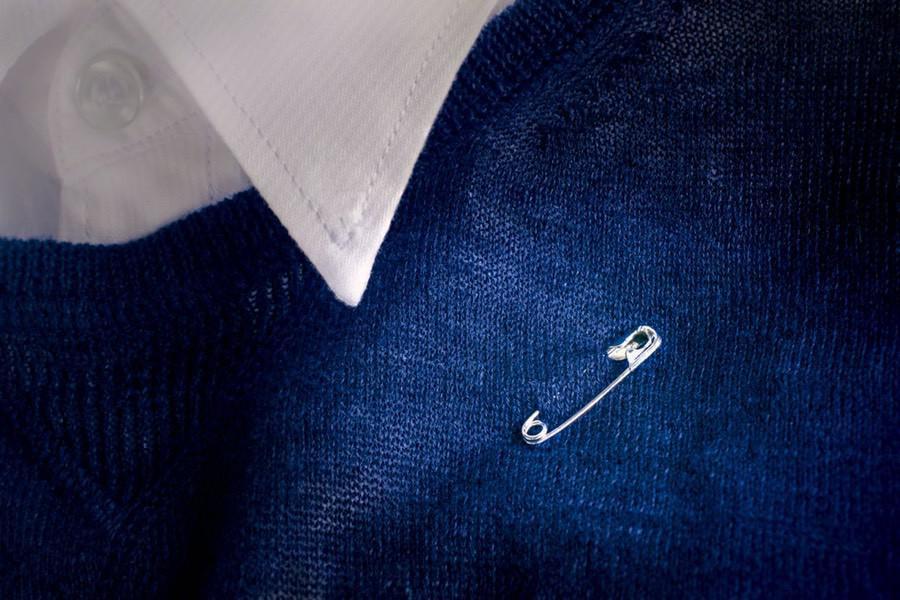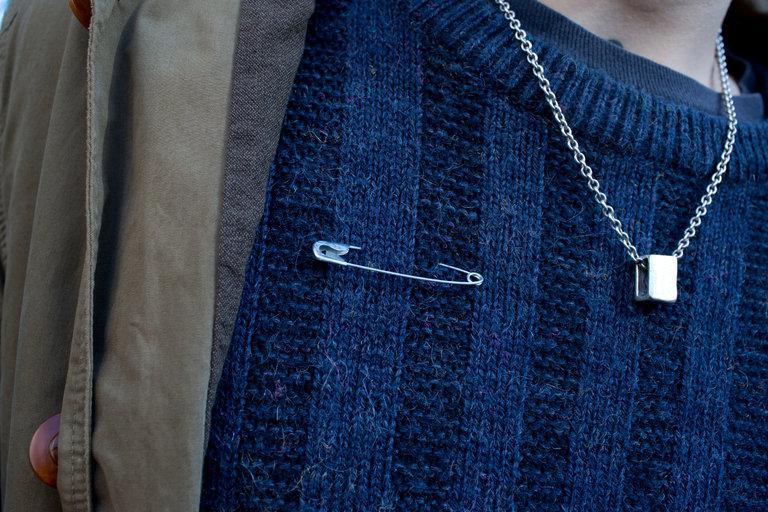The first image is the image on the left, the second image is the image on the right. Assess this claim about the two images: "The left image shows a single safety pin pinned on a blue cloth.". Correct or not? Answer yes or no. Yes. 